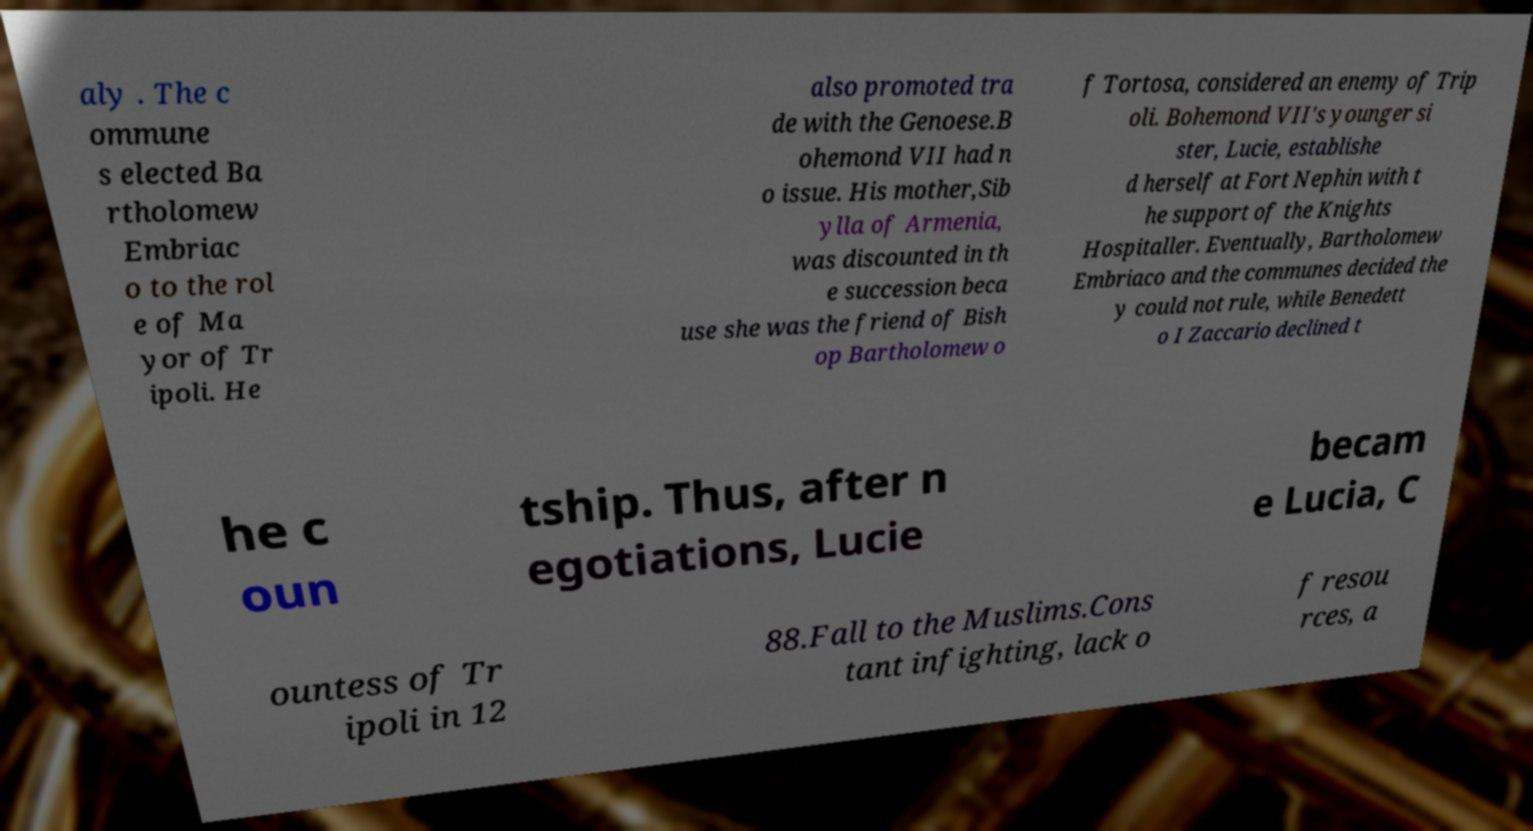Can you read and provide the text displayed in the image?This photo seems to have some interesting text. Can you extract and type it out for me? aly . The c ommune s elected Ba rtholomew Embriac o to the rol e of Ma yor of Tr ipoli. He also promoted tra de with the Genoese.B ohemond VII had n o issue. His mother,Sib ylla of Armenia, was discounted in th e succession beca use she was the friend of Bish op Bartholomew o f Tortosa, considered an enemy of Trip oli. Bohemond VII's younger si ster, Lucie, establishe d herself at Fort Nephin with t he support of the Knights Hospitaller. Eventually, Bartholomew Embriaco and the communes decided the y could not rule, while Benedett o I Zaccario declined t he c oun tship. Thus, after n egotiations, Lucie becam e Lucia, C ountess of Tr ipoli in 12 88.Fall to the Muslims.Cons tant infighting, lack o f resou rces, a 